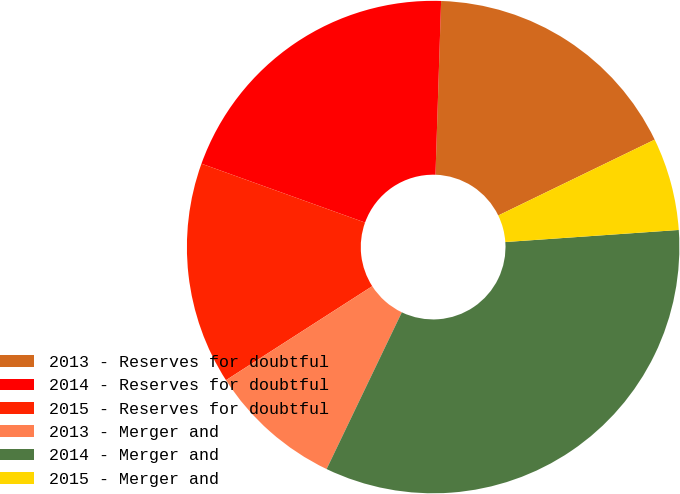Convert chart to OTSL. <chart><loc_0><loc_0><loc_500><loc_500><pie_chart><fcel>2013 - Reserves for doubtful<fcel>2014 - Reserves for doubtful<fcel>2015 - Reserves for doubtful<fcel>2013 - Merger and<fcel>2014 - Merger and<fcel>2015 - Merger and<nl><fcel>17.3%<fcel>20.02%<fcel>14.59%<fcel>8.79%<fcel>33.23%<fcel>6.08%<nl></chart> 